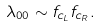<formula> <loc_0><loc_0><loc_500><loc_500>\lambda _ { 0 0 } \sim f _ { c _ { L } } f _ { c _ { R } } .</formula> 